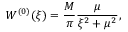<formula> <loc_0><loc_0><loc_500><loc_500>W ^ { ( 0 ) } ( \xi ) = \frac { M } { \pi } \frac { \mu } { \xi ^ { 2 } + \mu ^ { 2 } } ,</formula> 